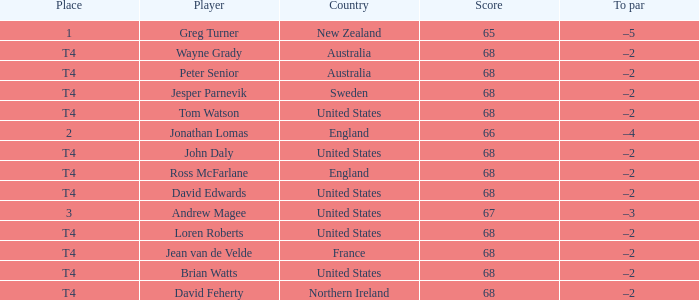Who has a To par of –2, and a Country of united states? John Daly, David Edwards, Loren Roberts, Tom Watson, Brian Watts. 